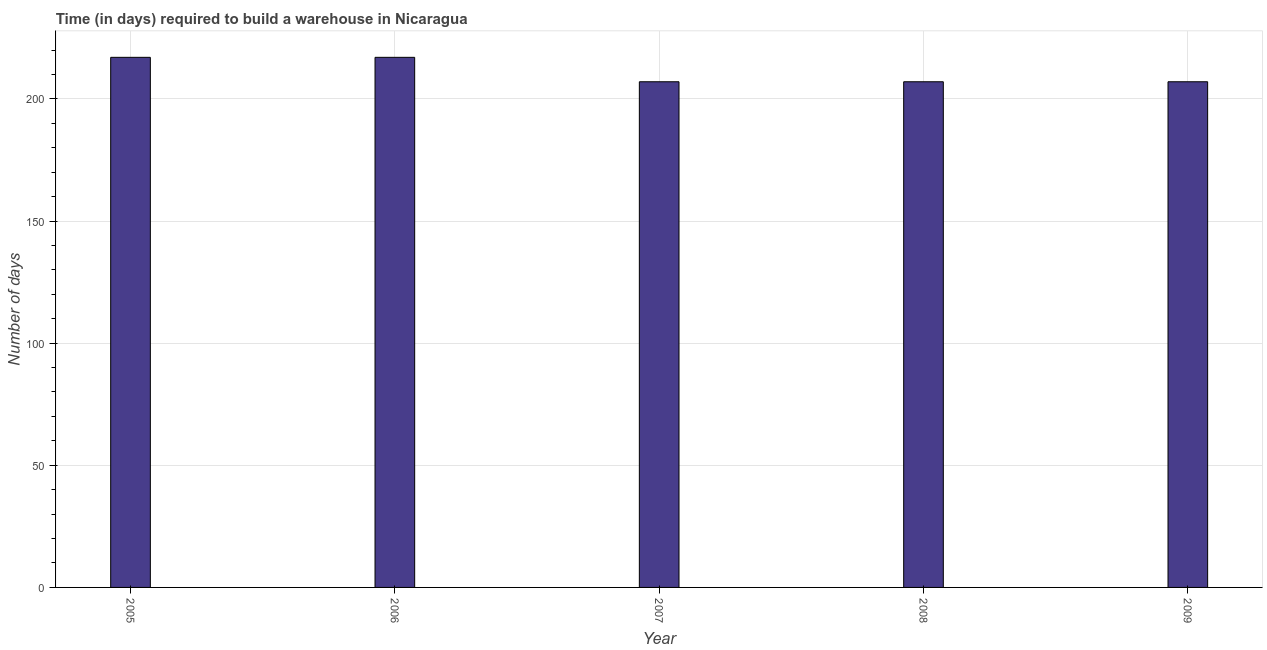Does the graph contain grids?
Offer a terse response. Yes. What is the title of the graph?
Your answer should be very brief. Time (in days) required to build a warehouse in Nicaragua. What is the label or title of the Y-axis?
Make the answer very short. Number of days. What is the time required to build a warehouse in 2007?
Offer a terse response. 207. Across all years, what is the maximum time required to build a warehouse?
Your response must be concise. 217. Across all years, what is the minimum time required to build a warehouse?
Provide a succinct answer. 207. In which year was the time required to build a warehouse maximum?
Offer a terse response. 2005. What is the sum of the time required to build a warehouse?
Offer a very short reply. 1055. What is the difference between the time required to build a warehouse in 2005 and 2007?
Your answer should be compact. 10. What is the average time required to build a warehouse per year?
Provide a short and direct response. 211. What is the median time required to build a warehouse?
Give a very brief answer. 207. In how many years, is the time required to build a warehouse greater than 100 days?
Offer a very short reply. 5. Do a majority of the years between 2008 and 2007 (inclusive) have time required to build a warehouse greater than 180 days?
Your answer should be compact. No. What is the ratio of the time required to build a warehouse in 2005 to that in 2007?
Offer a terse response. 1.05. Is the time required to build a warehouse in 2006 less than that in 2009?
Keep it short and to the point. No. What is the difference between the highest and the lowest time required to build a warehouse?
Give a very brief answer. 10. How many bars are there?
Provide a succinct answer. 5. Are all the bars in the graph horizontal?
Offer a very short reply. No. How many years are there in the graph?
Give a very brief answer. 5. What is the difference between two consecutive major ticks on the Y-axis?
Offer a terse response. 50. Are the values on the major ticks of Y-axis written in scientific E-notation?
Your response must be concise. No. What is the Number of days of 2005?
Offer a terse response. 217. What is the Number of days in 2006?
Provide a short and direct response. 217. What is the Number of days of 2007?
Offer a terse response. 207. What is the Number of days of 2008?
Your response must be concise. 207. What is the Number of days of 2009?
Your response must be concise. 207. What is the difference between the Number of days in 2005 and 2007?
Keep it short and to the point. 10. What is the difference between the Number of days in 2005 and 2008?
Provide a short and direct response. 10. What is the difference between the Number of days in 2006 and 2007?
Keep it short and to the point. 10. What is the difference between the Number of days in 2006 and 2008?
Provide a succinct answer. 10. What is the difference between the Number of days in 2007 and 2008?
Make the answer very short. 0. What is the difference between the Number of days in 2007 and 2009?
Your response must be concise. 0. What is the difference between the Number of days in 2008 and 2009?
Make the answer very short. 0. What is the ratio of the Number of days in 2005 to that in 2007?
Keep it short and to the point. 1.05. What is the ratio of the Number of days in 2005 to that in 2008?
Offer a terse response. 1.05. What is the ratio of the Number of days in 2005 to that in 2009?
Provide a short and direct response. 1.05. What is the ratio of the Number of days in 2006 to that in 2007?
Provide a short and direct response. 1.05. What is the ratio of the Number of days in 2006 to that in 2008?
Provide a short and direct response. 1.05. What is the ratio of the Number of days in 2006 to that in 2009?
Offer a very short reply. 1.05. What is the ratio of the Number of days in 2008 to that in 2009?
Offer a terse response. 1. 